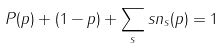<formula> <loc_0><loc_0><loc_500><loc_500>P ( p ) + ( 1 - p ) + \sum _ { s } s n _ { s } ( p ) = 1</formula> 